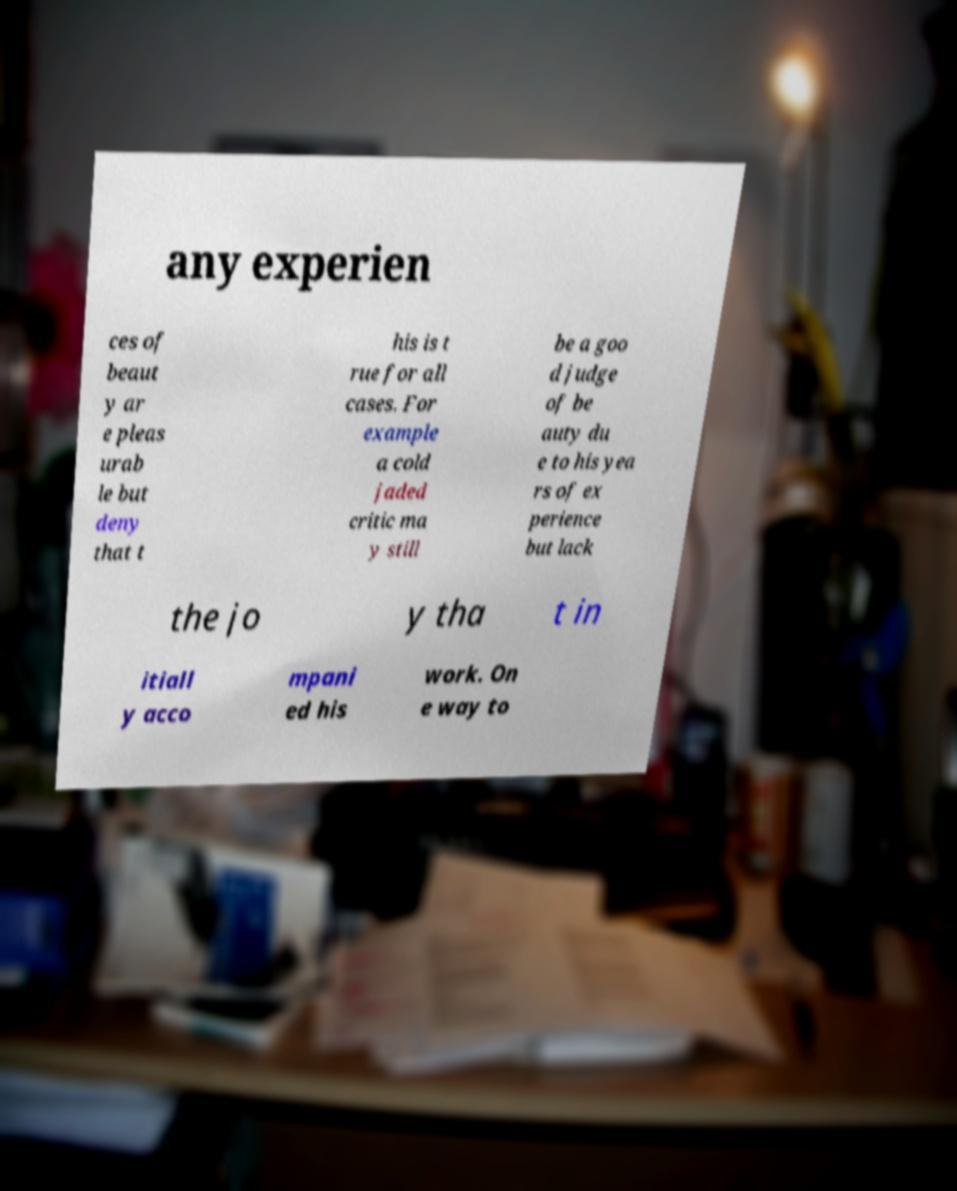Can you accurately transcribe the text from the provided image for me? any experien ces of beaut y ar e pleas urab le but deny that t his is t rue for all cases. For example a cold jaded critic ma y still be a goo d judge of be auty du e to his yea rs of ex perience but lack the jo y tha t in itiall y acco mpani ed his work. On e way to 